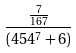<formula> <loc_0><loc_0><loc_500><loc_500>\frac { \frac { 7 } { 1 6 7 } } { ( 4 5 4 ^ { 7 } + 6 ) }</formula> 